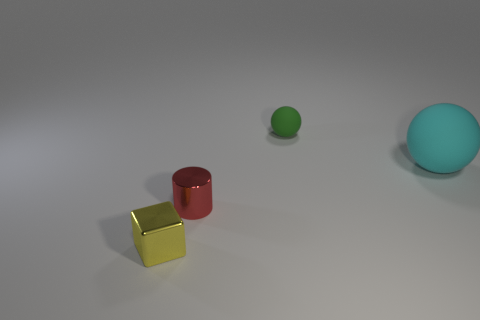What can you infer about the lighting and mood of the setting? The lighting in the image is soft and diffuse, creating gentle shadows to the right of each object, which suggests an indoor setting with ambient light sources. The lack of harsh shadows or bright spots indicates that the light sources are not very close to the objects. The overall mood conveyed by the lighting and the neutral background is calm and neutral, focusing attention on the objects themselves without emotional bias. 